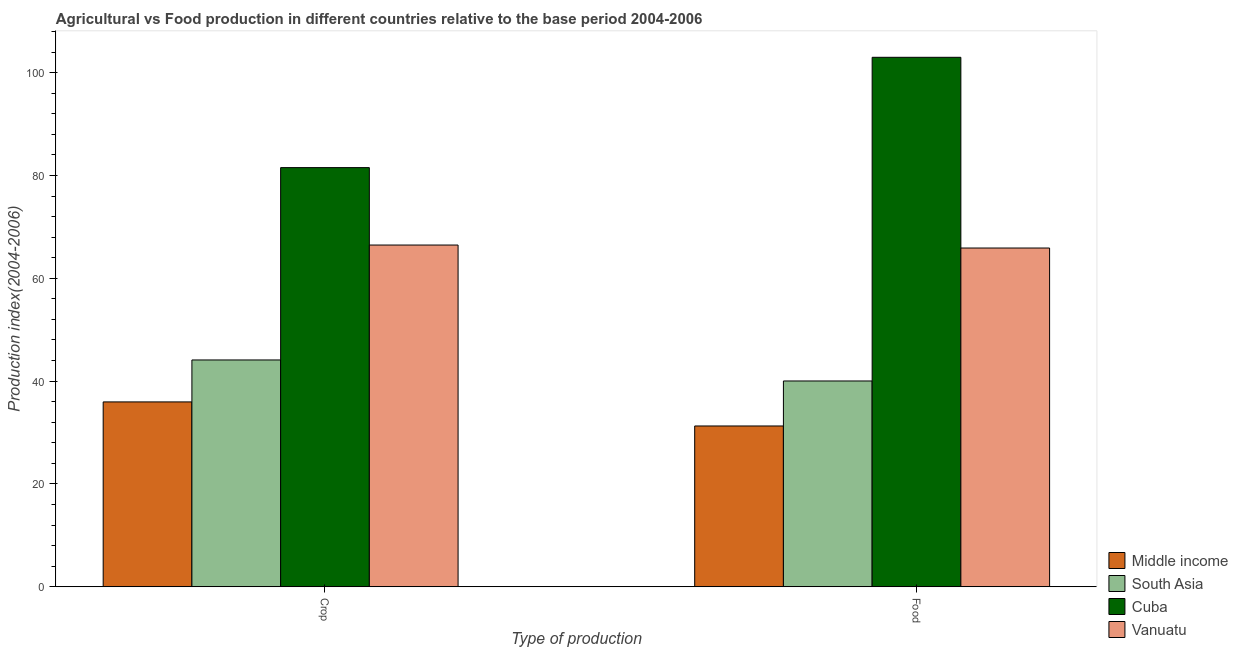How many groups of bars are there?
Offer a very short reply. 2. How many bars are there on the 1st tick from the left?
Your answer should be very brief. 4. How many bars are there on the 1st tick from the right?
Offer a very short reply. 4. What is the label of the 2nd group of bars from the left?
Keep it short and to the point. Food. What is the food production index in Cuba?
Your answer should be very brief. 102.99. Across all countries, what is the maximum crop production index?
Your response must be concise. 81.53. Across all countries, what is the minimum food production index?
Your response must be concise. 31.27. In which country was the food production index maximum?
Provide a succinct answer. Cuba. In which country was the crop production index minimum?
Offer a terse response. Middle income. What is the total crop production index in the graph?
Keep it short and to the point. 228.07. What is the difference between the crop production index in Vanuatu and that in Cuba?
Keep it short and to the point. -15.06. What is the difference between the crop production index in South Asia and the food production index in Middle income?
Ensure brevity in your answer.  12.84. What is the average crop production index per country?
Offer a very short reply. 57.02. What is the difference between the crop production index and food production index in South Asia?
Ensure brevity in your answer.  4.09. What is the ratio of the crop production index in Vanuatu to that in South Asia?
Your answer should be very brief. 1.51. In how many countries, is the crop production index greater than the average crop production index taken over all countries?
Offer a very short reply. 2. What does the 3rd bar from the left in Crop represents?
Provide a short and direct response. Cuba. What does the 1st bar from the right in Food represents?
Offer a very short reply. Vanuatu. How many bars are there?
Make the answer very short. 8. What is the difference between two consecutive major ticks on the Y-axis?
Offer a terse response. 20. Are the values on the major ticks of Y-axis written in scientific E-notation?
Make the answer very short. No. Does the graph contain grids?
Give a very brief answer. No. How are the legend labels stacked?
Provide a succinct answer. Vertical. What is the title of the graph?
Your answer should be very brief. Agricultural vs Food production in different countries relative to the base period 2004-2006. What is the label or title of the X-axis?
Your answer should be compact. Type of production. What is the label or title of the Y-axis?
Provide a succinct answer. Production index(2004-2006). What is the Production index(2004-2006) of Middle income in Crop?
Your response must be concise. 35.96. What is the Production index(2004-2006) of South Asia in Crop?
Make the answer very short. 44.12. What is the Production index(2004-2006) of Cuba in Crop?
Your answer should be compact. 81.53. What is the Production index(2004-2006) of Vanuatu in Crop?
Offer a terse response. 66.47. What is the Production index(2004-2006) of Middle income in Food?
Provide a succinct answer. 31.27. What is the Production index(2004-2006) of South Asia in Food?
Ensure brevity in your answer.  40.03. What is the Production index(2004-2006) of Cuba in Food?
Your answer should be compact. 102.99. What is the Production index(2004-2006) of Vanuatu in Food?
Offer a terse response. 65.89. Across all Type of production, what is the maximum Production index(2004-2006) of Middle income?
Offer a very short reply. 35.96. Across all Type of production, what is the maximum Production index(2004-2006) in South Asia?
Your answer should be compact. 44.12. Across all Type of production, what is the maximum Production index(2004-2006) in Cuba?
Offer a terse response. 102.99. Across all Type of production, what is the maximum Production index(2004-2006) of Vanuatu?
Ensure brevity in your answer.  66.47. Across all Type of production, what is the minimum Production index(2004-2006) in Middle income?
Give a very brief answer. 31.27. Across all Type of production, what is the minimum Production index(2004-2006) in South Asia?
Offer a very short reply. 40.03. Across all Type of production, what is the minimum Production index(2004-2006) of Cuba?
Give a very brief answer. 81.53. Across all Type of production, what is the minimum Production index(2004-2006) in Vanuatu?
Offer a terse response. 65.89. What is the total Production index(2004-2006) of Middle income in the graph?
Offer a very short reply. 67.23. What is the total Production index(2004-2006) of South Asia in the graph?
Offer a very short reply. 84.14. What is the total Production index(2004-2006) in Cuba in the graph?
Provide a succinct answer. 184.52. What is the total Production index(2004-2006) in Vanuatu in the graph?
Provide a succinct answer. 132.36. What is the difference between the Production index(2004-2006) in Middle income in Crop and that in Food?
Offer a terse response. 4.68. What is the difference between the Production index(2004-2006) of South Asia in Crop and that in Food?
Make the answer very short. 4.09. What is the difference between the Production index(2004-2006) in Cuba in Crop and that in Food?
Ensure brevity in your answer.  -21.46. What is the difference between the Production index(2004-2006) in Vanuatu in Crop and that in Food?
Offer a terse response. 0.58. What is the difference between the Production index(2004-2006) of Middle income in Crop and the Production index(2004-2006) of South Asia in Food?
Your answer should be very brief. -4.07. What is the difference between the Production index(2004-2006) in Middle income in Crop and the Production index(2004-2006) in Cuba in Food?
Your answer should be compact. -67.03. What is the difference between the Production index(2004-2006) of Middle income in Crop and the Production index(2004-2006) of Vanuatu in Food?
Your answer should be compact. -29.93. What is the difference between the Production index(2004-2006) in South Asia in Crop and the Production index(2004-2006) in Cuba in Food?
Make the answer very short. -58.87. What is the difference between the Production index(2004-2006) of South Asia in Crop and the Production index(2004-2006) of Vanuatu in Food?
Keep it short and to the point. -21.77. What is the difference between the Production index(2004-2006) of Cuba in Crop and the Production index(2004-2006) of Vanuatu in Food?
Keep it short and to the point. 15.64. What is the average Production index(2004-2006) in Middle income per Type of production?
Make the answer very short. 33.62. What is the average Production index(2004-2006) of South Asia per Type of production?
Offer a terse response. 42.07. What is the average Production index(2004-2006) in Cuba per Type of production?
Make the answer very short. 92.26. What is the average Production index(2004-2006) of Vanuatu per Type of production?
Ensure brevity in your answer.  66.18. What is the difference between the Production index(2004-2006) in Middle income and Production index(2004-2006) in South Asia in Crop?
Ensure brevity in your answer.  -8.16. What is the difference between the Production index(2004-2006) in Middle income and Production index(2004-2006) in Cuba in Crop?
Give a very brief answer. -45.57. What is the difference between the Production index(2004-2006) of Middle income and Production index(2004-2006) of Vanuatu in Crop?
Make the answer very short. -30.51. What is the difference between the Production index(2004-2006) of South Asia and Production index(2004-2006) of Cuba in Crop?
Give a very brief answer. -37.41. What is the difference between the Production index(2004-2006) of South Asia and Production index(2004-2006) of Vanuatu in Crop?
Provide a succinct answer. -22.35. What is the difference between the Production index(2004-2006) of Cuba and Production index(2004-2006) of Vanuatu in Crop?
Keep it short and to the point. 15.06. What is the difference between the Production index(2004-2006) of Middle income and Production index(2004-2006) of South Asia in Food?
Your answer should be very brief. -8.75. What is the difference between the Production index(2004-2006) of Middle income and Production index(2004-2006) of Cuba in Food?
Ensure brevity in your answer.  -71.72. What is the difference between the Production index(2004-2006) in Middle income and Production index(2004-2006) in Vanuatu in Food?
Offer a very short reply. -34.62. What is the difference between the Production index(2004-2006) in South Asia and Production index(2004-2006) in Cuba in Food?
Provide a succinct answer. -62.96. What is the difference between the Production index(2004-2006) in South Asia and Production index(2004-2006) in Vanuatu in Food?
Provide a short and direct response. -25.86. What is the difference between the Production index(2004-2006) in Cuba and Production index(2004-2006) in Vanuatu in Food?
Your answer should be very brief. 37.1. What is the ratio of the Production index(2004-2006) in Middle income in Crop to that in Food?
Offer a terse response. 1.15. What is the ratio of the Production index(2004-2006) in South Asia in Crop to that in Food?
Your answer should be very brief. 1.1. What is the ratio of the Production index(2004-2006) in Cuba in Crop to that in Food?
Offer a terse response. 0.79. What is the ratio of the Production index(2004-2006) in Vanuatu in Crop to that in Food?
Your answer should be compact. 1.01. What is the difference between the highest and the second highest Production index(2004-2006) in Middle income?
Offer a very short reply. 4.68. What is the difference between the highest and the second highest Production index(2004-2006) of South Asia?
Offer a very short reply. 4.09. What is the difference between the highest and the second highest Production index(2004-2006) in Cuba?
Your response must be concise. 21.46. What is the difference between the highest and the second highest Production index(2004-2006) in Vanuatu?
Offer a very short reply. 0.58. What is the difference between the highest and the lowest Production index(2004-2006) in Middle income?
Your response must be concise. 4.68. What is the difference between the highest and the lowest Production index(2004-2006) of South Asia?
Provide a succinct answer. 4.09. What is the difference between the highest and the lowest Production index(2004-2006) in Cuba?
Provide a short and direct response. 21.46. What is the difference between the highest and the lowest Production index(2004-2006) of Vanuatu?
Ensure brevity in your answer.  0.58. 